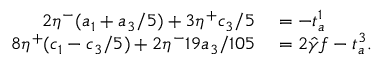Convert formula to latex. <formula><loc_0><loc_0><loc_500><loc_500>\begin{array} { r l } { 2 \eta ^ { - } ( a _ { 1 } + a _ { 3 } / 5 ) + 3 \eta ^ { + } c _ { 3 } / 5 } & = - t _ { a } ^ { 1 } } \\ { 8 \eta ^ { + } ( c _ { 1 } - c _ { 3 } / 5 ) + 2 \eta ^ { - } 1 9 a _ { 3 } / 1 0 5 } & = 2 { \hat { \gamma } } f - t _ { a } ^ { 3 } . } \end{array}</formula> 